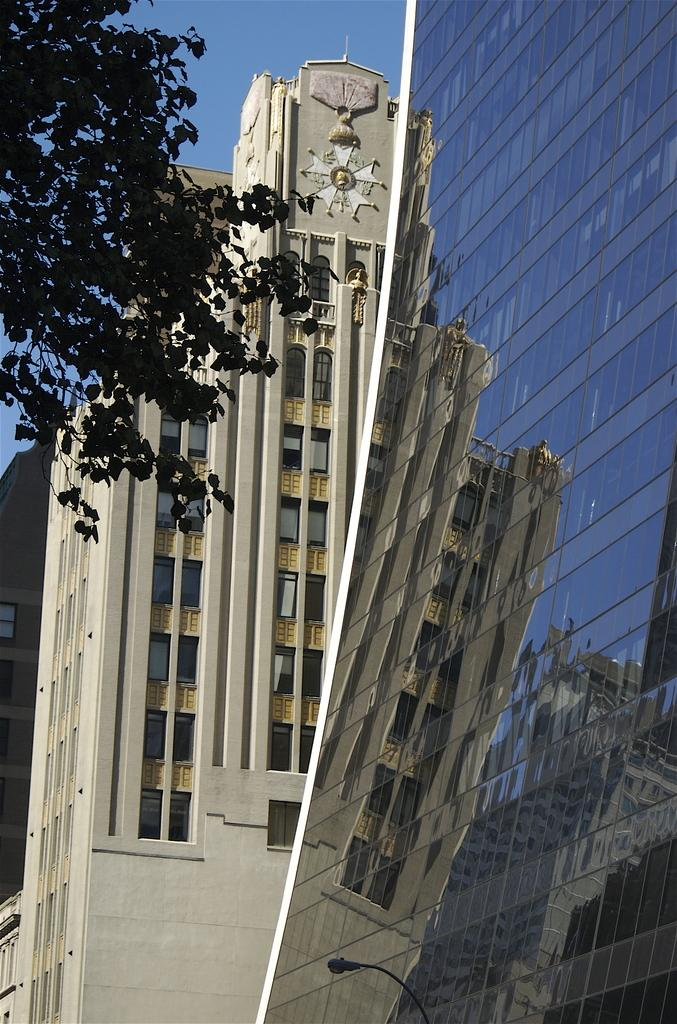What type of structures can be seen in the image? There are buildings in the image. What type of vegetation is present in the image? There is a tree in the image. What is visible in the background of the image? The sky is visible in the background of the image. What color is the sky in the image? The sky is blue in the image. Can you see any bones in the image? There are no bones present in the image. What type of cheese is being used to decorate the buildings in the image? There is no cheese present in the image; it features buildings, a tree, and a blue sky. 